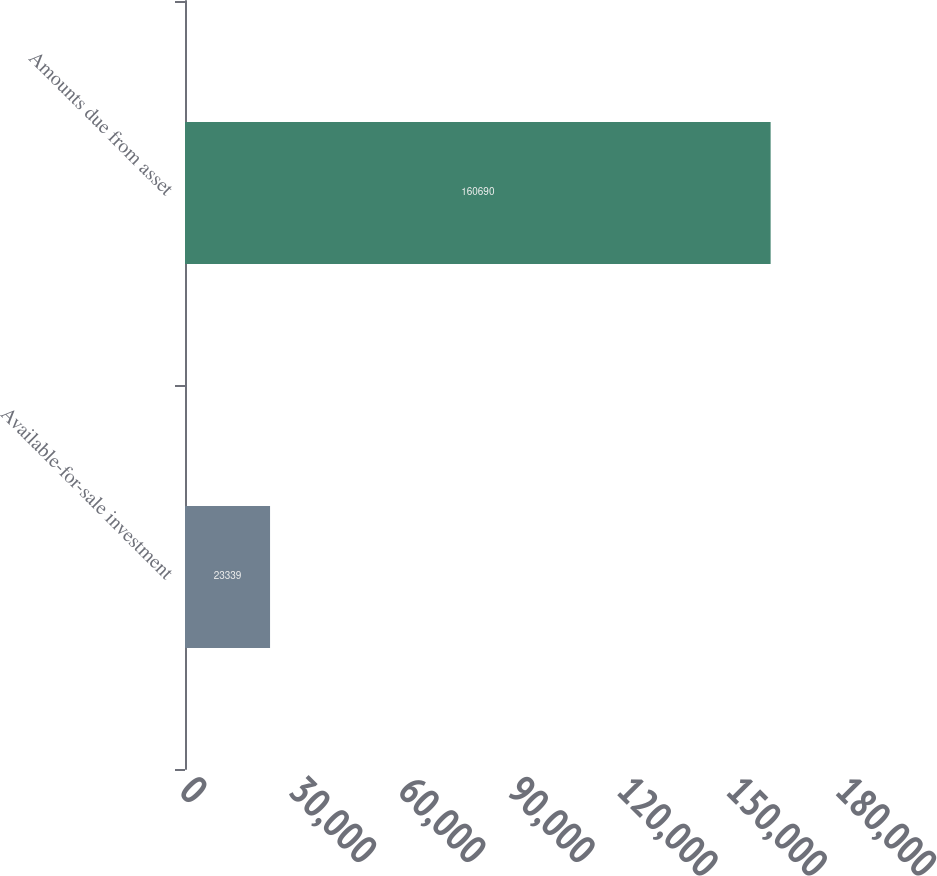Convert chart to OTSL. <chart><loc_0><loc_0><loc_500><loc_500><bar_chart><fcel>Available-for-sale investment<fcel>Amounts due from asset<nl><fcel>23339<fcel>160690<nl></chart> 